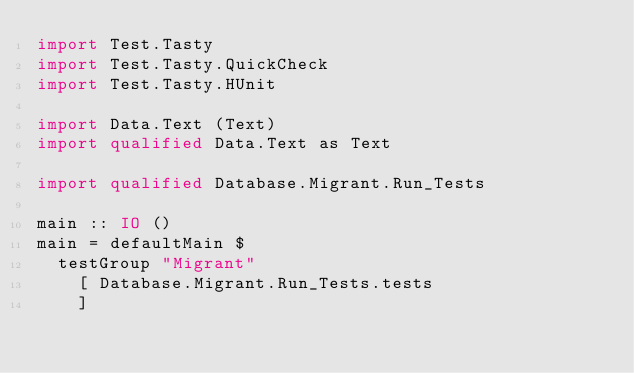Convert code to text. <code><loc_0><loc_0><loc_500><loc_500><_Haskell_>import Test.Tasty
import Test.Tasty.QuickCheck
import Test.Tasty.HUnit

import Data.Text (Text)
import qualified Data.Text as Text

import qualified Database.Migrant.Run_Tests

main :: IO ()
main = defaultMain $
  testGroup "Migrant"
    [ Database.Migrant.Run_Tests.tests
    ]
</code> 